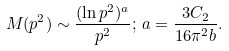Convert formula to latex. <formula><loc_0><loc_0><loc_500><loc_500>M ( p ^ { 2 } ) \sim \frac { ( \ln p ^ { 2 } ) ^ { a } } { p ^ { 2 } } ; \, a = \frac { 3 C _ { 2 } } { 1 6 \pi ^ { 2 } b } .</formula> 